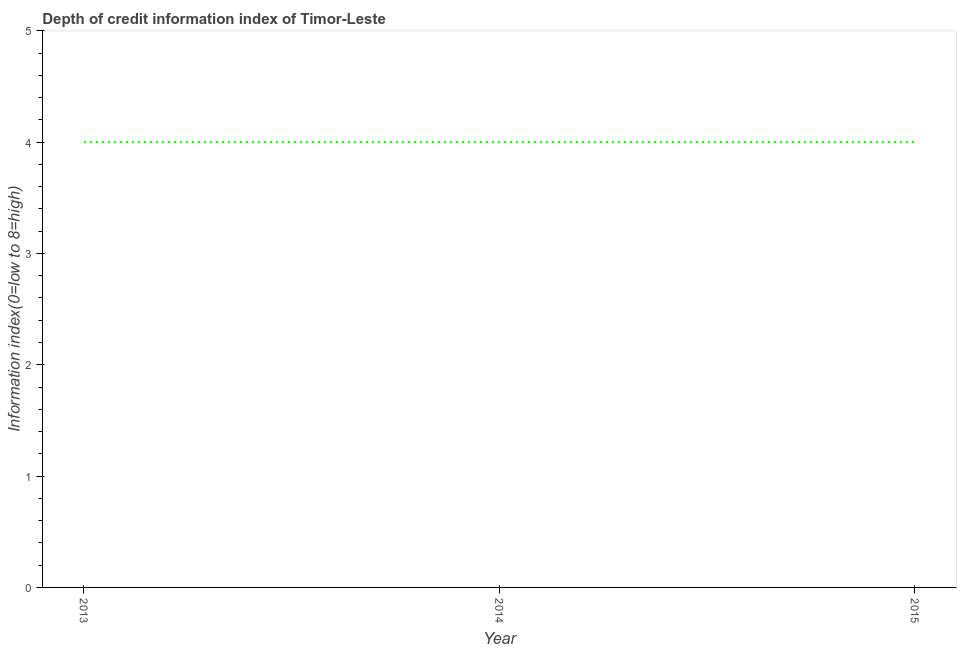What is the depth of credit information index in 2013?
Offer a terse response. 4. Across all years, what is the maximum depth of credit information index?
Keep it short and to the point. 4. Across all years, what is the minimum depth of credit information index?
Provide a succinct answer. 4. What is the sum of the depth of credit information index?
Keep it short and to the point. 12. What is the average depth of credit information index per year?
Offer a terse response. 4. In how many years, is the depth of credit information index greater than 3.4 ?
Give a very brief answer. 3. Do a majority of the years between 2013 and 2014 (inclusive) have depth of credit information index greater than 2.6 ?
Offer a terse response. Yes. What is the difference between the highest and the second highest depth of credit information index?
Your response must be concise. 0. Is the sum of the depth of credit information index in 2013 and 2015 greater than the maximum depth of credit information index across all years?
Offer a very short reply. Yes. In how many years, is the depth of credit information index greater than the average depth of credit information index taken over all years?
Your response must be concise. 0. Does the depth of credit information index monotonically increase over the years?
Offer a terse response. No. How many lines are there?
Make the answer very short. 1. What is the difference between two consecutive major ticks on the Y-axis?
Keep it short and to the point. 1. Are the values on the major ticks of Y-axis written in scientific E-notation?
Your answer should be compact. No. What is the title of the graph?
Your answer should be compact. Depth of credit information index of Timor-Leste. What is the label or title of the X-axis?
Give a very brief answer. Year. What is the label or title of the Y-axis?
Give a very brief answer. Information index(0=low to 8=high). What is the Information index(0=low to 8=high) in 2014?
Your answer should be compact. 4. What is the Information index(0=low to 8=high) in 2015?
Keep it short and to the point. 4. What is the difference between the Information index(0=low to 8=high) in 2013 and 2015?
Your answer should be compact. 0. What is the difference between the Information index(0=low to 8=high) in 2014 and 2015?
Your answer should be compact. 0. What is the ratio of the Information index(0=low to 8=high) in 2013 to that in 2014?
Your answer should be compact. 1. 